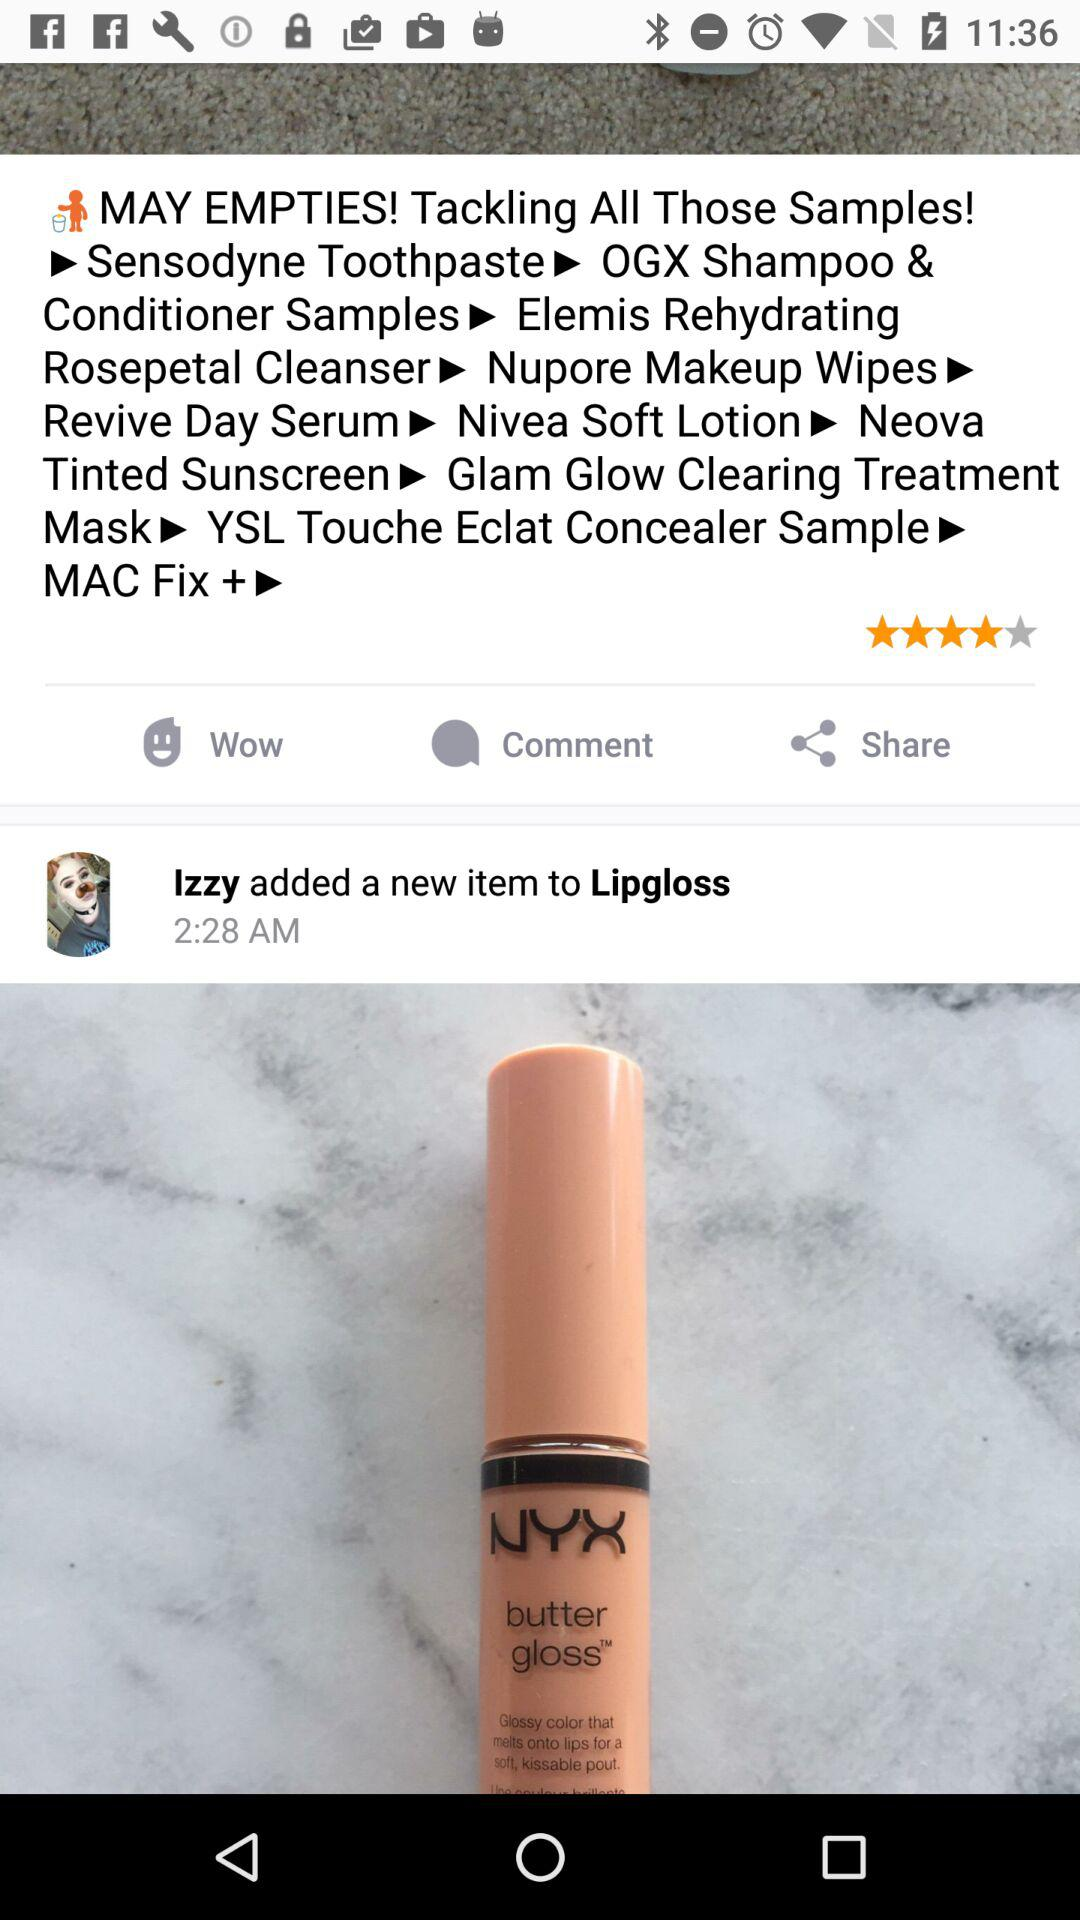At what time did lzzy add the new item? Izzy added the new item at 2:28 AM. 